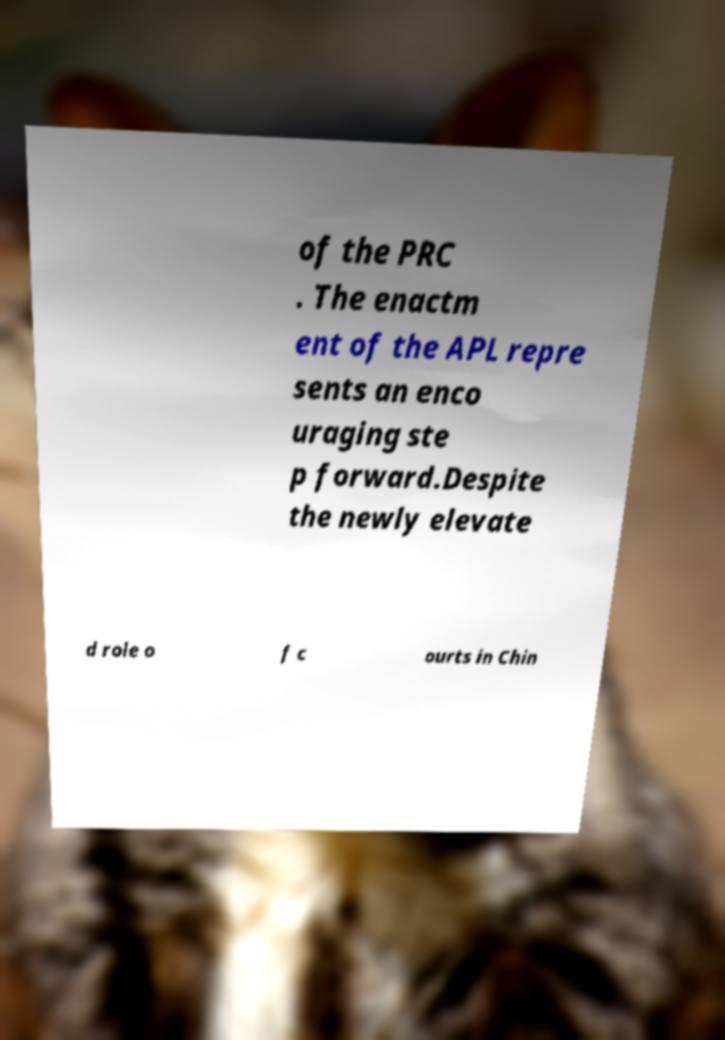What messages or text are displayed in this image? I need them in a readable, typed format. of the PRC . The enactm ent of the APL repre sents an enco uraging ste p forward.Despite the newly elevate d role o f c ourts in Chin 